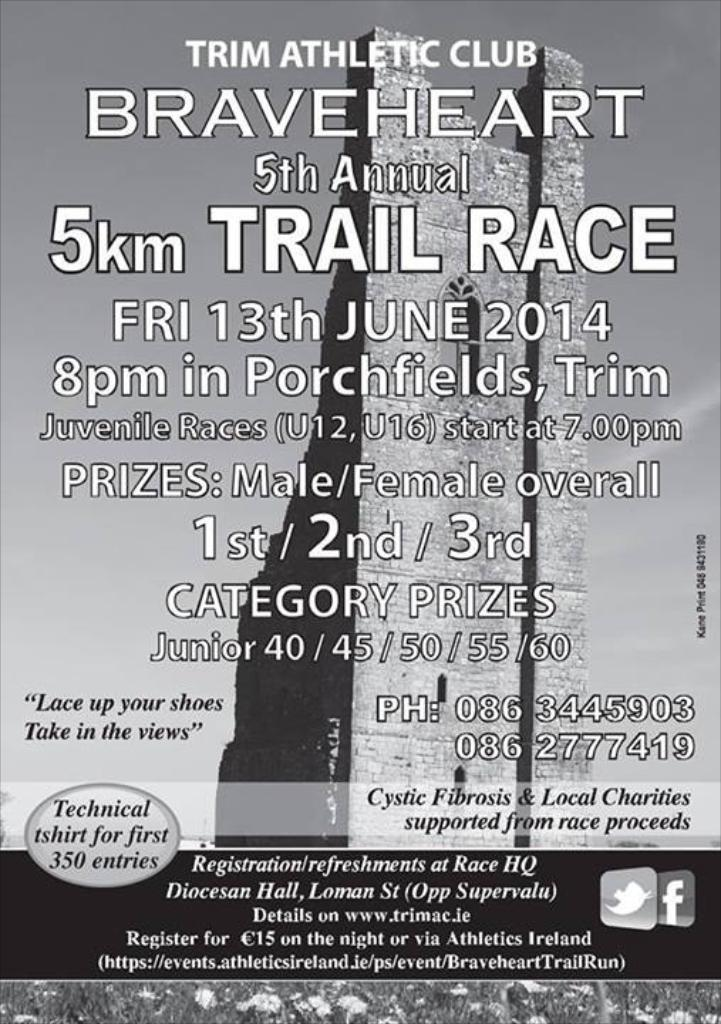<image>
Share a concise interpretation of the image provided. A poster advertises the Trim Athletic Club Braveheart 5th Annual 5km Trail Race on Friday, June 13 2014. 